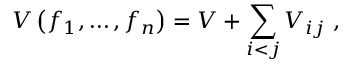Convert formula to latex. <formula><loc_0><loc_0><loc_500><loc_500>V \left ( f _ { 1 } , \dots , f _ { n } \right ) = V + \sum _ { i < j } V _ { i j } \ ,</formula> 